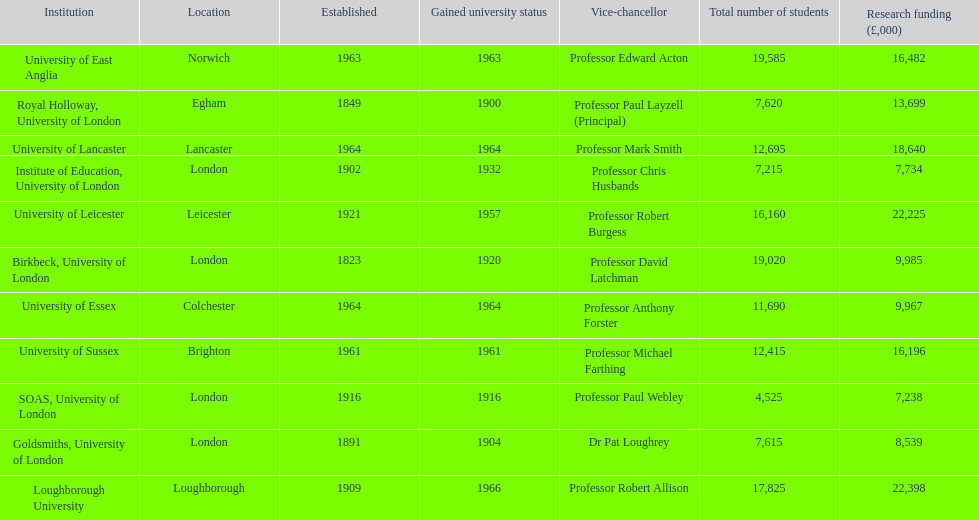Which institution has the most research funding? Loughborough University. 